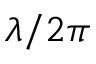Convert formula to latex. <formula><loc_0><loc_0><loc_500><loc_500>\lambda / 2 \pi</formula> 